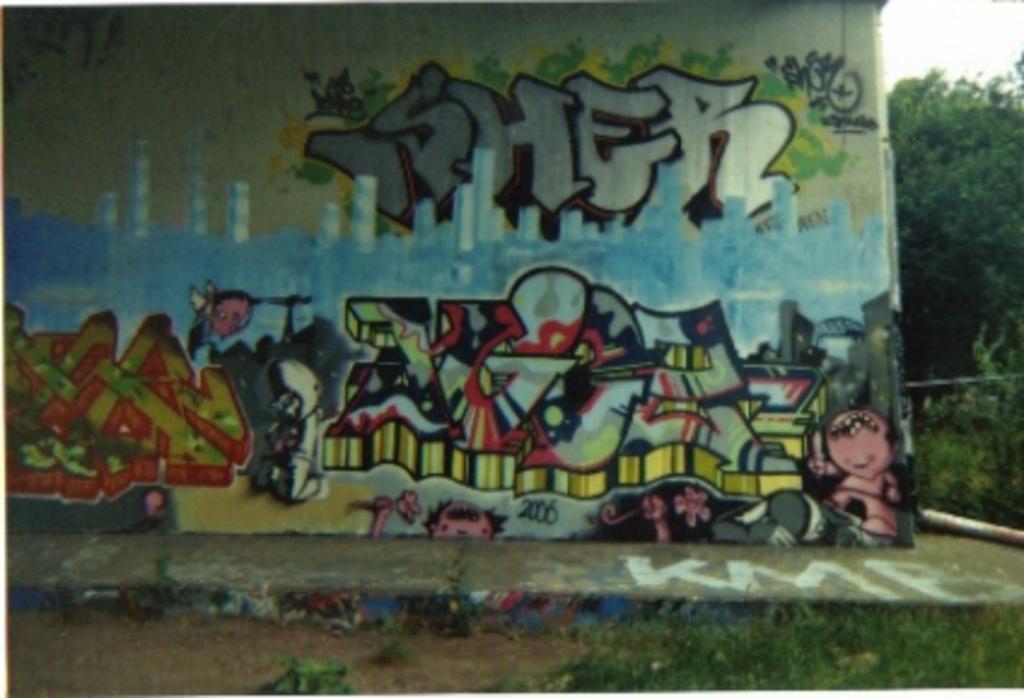In one or two sentences, can you explain what this image depicts? In this picture we can see painted wall, around we can see some trees and grass. 